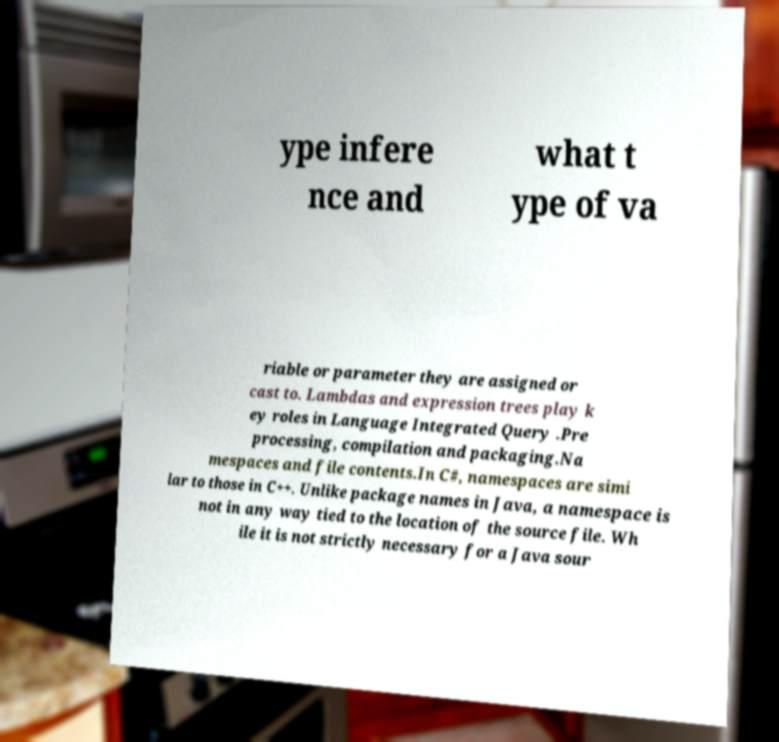Please identify and transcribe the text found in this image. ype infere nce and what t ype of va riable or parameter they are assigned or cast to. Lambdas and expression trees play k ey roles in Language Integrated Query .Pre processing, compilation and packaging.Na mespaces and file contents.In C#, namespaces are simi lar to those in C++. Unlike package names in Java, a namespace is not in any way tied to the location of the source file. Wh ile it is not strictly necessary for a Java sour 